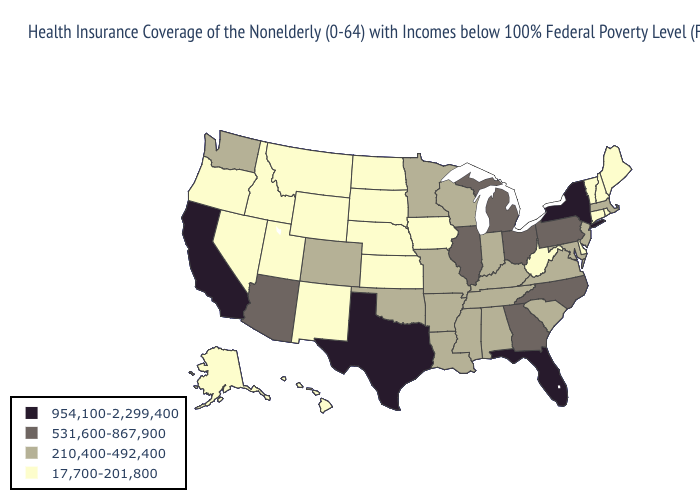Does Florida have the lowest value in the South?
Give a very brief answer. No. Does Texas have the highest value in the USA?
Concise answer only. Yes. What is the lowest value in the West?
Quick response, please. 17,700-201,800. Does Texas have a lower value than Alabama?
Write a very short answer. No. Which states have the highest value in the USA?
Concise answer only. California, Florida, New York, Texas. What is the value of Louisiana?
Concise answer only. 210,400-492,400. Name the states that have a value in the range 954,100-2,299,400?
Quick response, please. California, Florida, New York, Texas. What is the highest value in the USA?
Concise answer only. 954,100-2,299,400. What is the lowest value in the USA?
Short answer required. 17,700-201,800. Which states have the lowest value in the USA?
Be succinct. Alaska, Connecticut, Delaware, Hawaii, Idaho, Iowa, Kansas, Maine, Montana, Nebraska, Nevada, New Hampshire, New Mexico, North Dakota, Oregon, Rhode Island, South Dakota, Utah, Vermont, West Virginia, Wyoming. Which states hav the highest value in the MidWest?
Concise answer only. Illinois, Michigan, Ohio. What is the lowest value in the MidWest?
Concise answer only. 17,700-201,800. What is the lowest value in the South?
Keep it brief. 17,700-201,800. Name the states that have a value in the range 17,700-201,800?
Give a very brief answer. Alaska, Connecticut, Delaware, Hawaii, Idaho, Iowa, Kansas, Maine, Montana, Nebraska, Nevada, New Hampshire, New Mexico, North Dakota, Oregon, Rhode Island, South Dakota, Utah, Vermont, West Virginia, Wyoming. What is the lowest value in the USA?
Quick response, please. 17,700-201,800. 